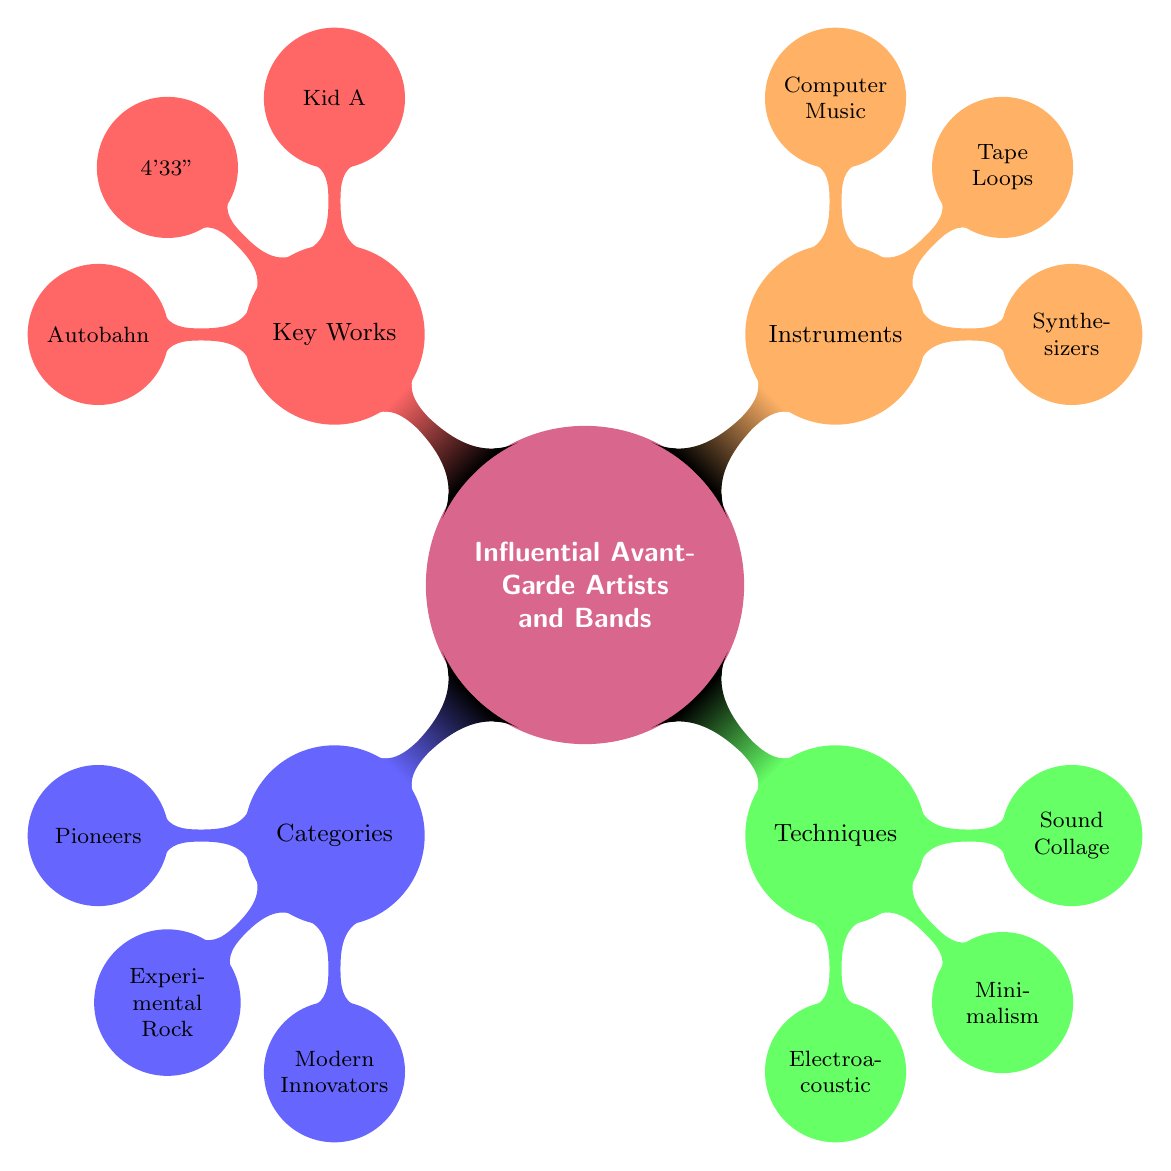What's the main central theme of the diagram? The central theme of the diagram is "Influential Avant-Garde Artists and Bands," which is indicated prominently at the center of the mind map.
Answer: Influential Avant-Garde Artists and Bands How many categories are there in the diagram? The diagram features four main categories, which include Categories, Techniques and Styles, Instruments and Technology, and Key Albums and Works.
Answer: 4 What is the name of the album associated with Radiohead? The album associated with Radiohead, as shown in the Key Albums and Works section, is "Kid A."
Answer: Kid A Who is listed as a pioneer in the diagram? "Stockhausen," "Cage," and "Varese" are mentioned under the Pioneers category, so any of these could be considered a pioneer.
Answer: Stockhausen Which technique is categorized under Techniques and Styles? The technique listed under Techniques and Styles includes "Electroacoustic," "Minimalism," and "Sound Collage." Any of these can be mentioned, but "Electroacoustic" is the first one listed.
Answer: Electroacoustic How many artists are there in the Experimental Rock and Electronic category? There are three artists listed under the Experimental Rock and Electronic category: Radiohead, The Velvet Underground, and Kraftwerk.
Answer: 3 Which album corresponds with the artist Bjork? The album corresponding with Bjork in the Key Albums and Works section is "Homogenic."
Answer: Homogenic What instrument is specifically mentioned in the Instruments and Technology section? The instruments specifically mentioned include Synthesizers, Tape Loops, and Computer Music, with "Synthesizers" being the first listed.
Answer: Synthesizers Which work is associated with 4'33"? The work associated with 4'33" is noted next to John Cage in the Key Albums and Works section.
Answer: 4'33" 